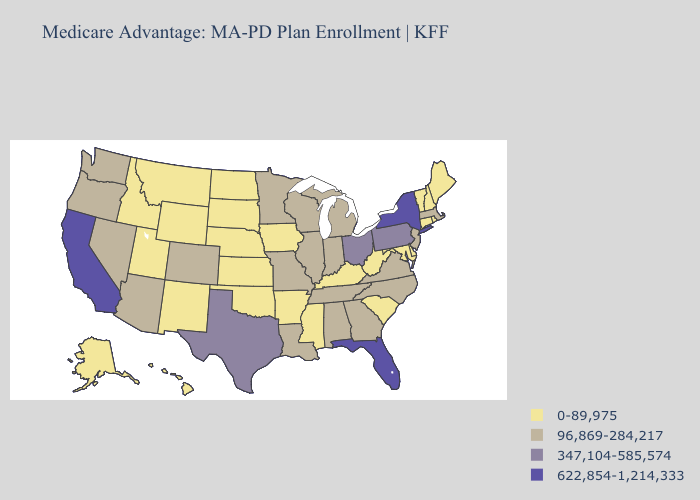What is the value of Wisconsin?
Give a very brief answer. 96,869-284,217. Does Missouri have the same value as Maine?
Write a very short answer. No. What is the highest value in the South ?
Keep it brief. 622,854-1,214,333. What is the lowest value in the USA?
Be succinct. 0-89,975. What is the value of Connecticut?
Concise answer only. 0-89,975. How many symbols are there in the legend?
Write a very short answer. 4. Does Minnesota have the lowest value in the MidWest?
Short answer required. No. Does the first symbol in the legend represent the smallest category?
Write a very short answer. Yes. What is the value of New York?
Concise answer only. 622,854-1,214,333. What is the value of Georgia?
Be succinct. 96,869-284,217. Does Hawaii have the highest value in the USA?
Answer briefly. No. What is the value of Wyoming?
Quick response, please. 0-89,975. What is the highest value in states that border Georgia?
Be succinct. 622,854-1,214,333. What is the lowest value in states that border North Carolina?
Give a very brief answer. 0-89,975. 